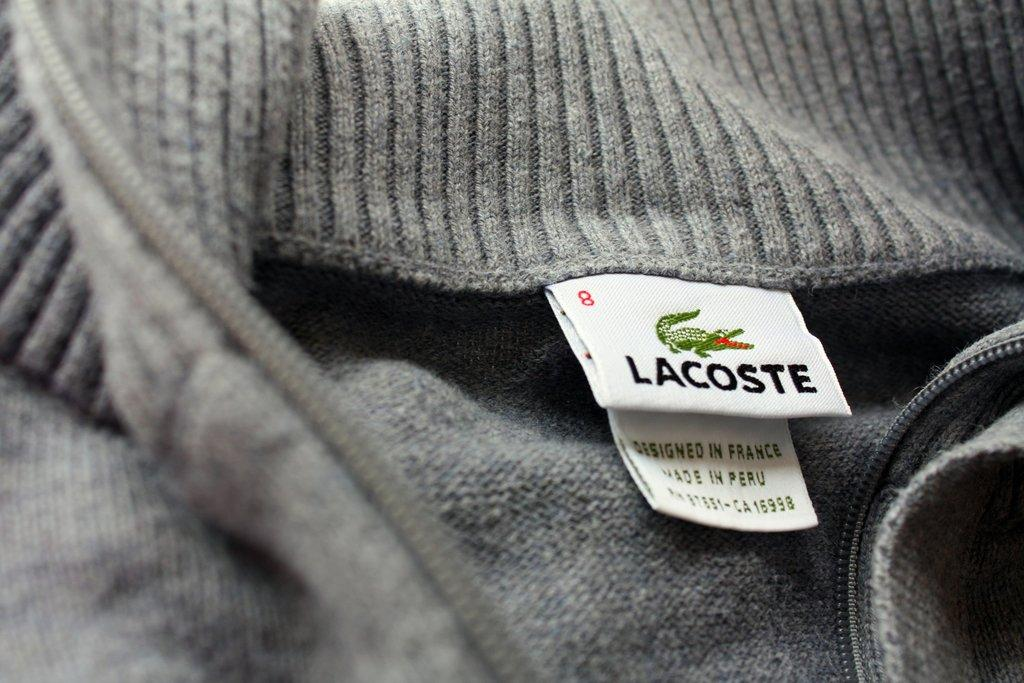What type of clothing item is present in the image? There is a gray color jacket in the image. What is on the jacket? The jacket has stickers on it. What colors are used for the text on the stickers? The stickers have black color text and green color text. How does the sleet affect the jacket in the image? There is no sleet present in the image, so its effect on the jacket cannot be determined. 